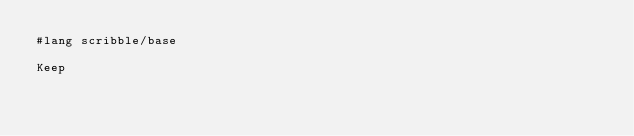Convert code to text. <code><loc_0><loc_0><loc_500><loc_500><_Racket_>#lang scribble/base

Keep
</code> 